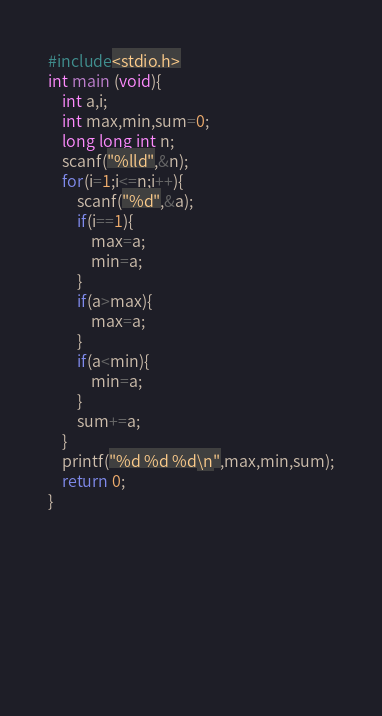<code> <loc_0><loc_0><loc_500><loc_500><_C_>#include<stdio.h>
int main (void){
    int a,i;
    int max,min,sum=0;
    long long int n;
    scanf("%lld",&n);
    for(i=1;i<=n;i++){
        scanf("%d",&a);
        if(i==1){
            max=a;
            min=a;
        }
        if(a>max){
            max=a;
        }
        if(a<min){
            min=a;
        }
        sum+=a;
    }
    printf("%d %d %d\n",max,min,sum);
    return 0;
}
        
        
            
            
            
    
    
 </code> 